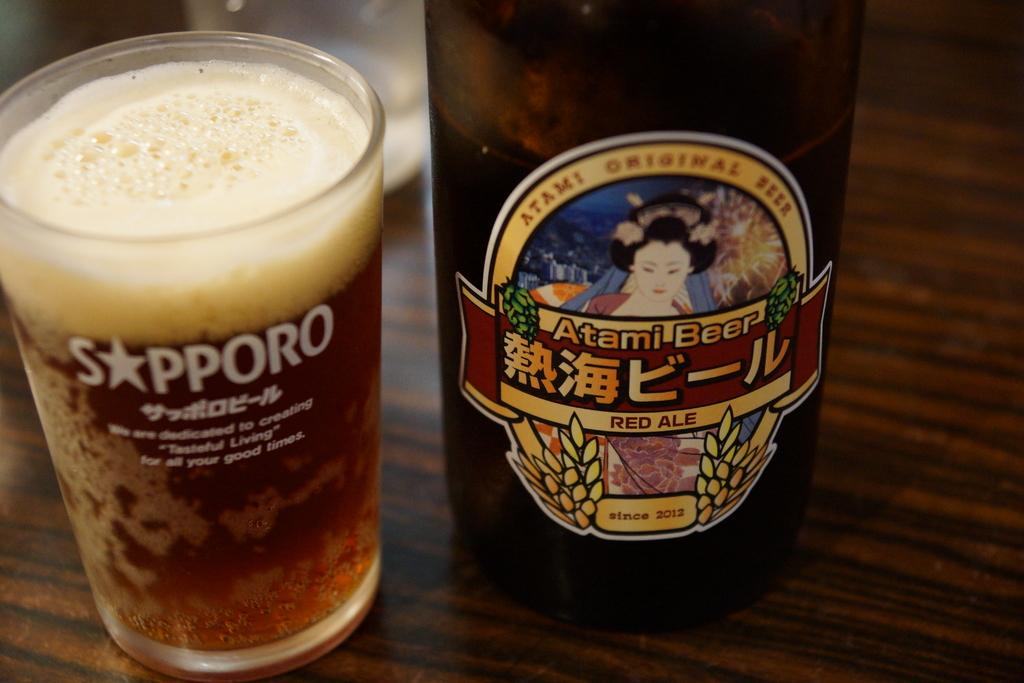What is in the glass that is visible in the image? There is a drink in the glass in the image. What else can be seen in the image besides the glass? There is a bottle in the image. Can you describe the bottle in more detail? There is a sticker on the bottle. What crime is being committed in the image? There is no crime being committed in the image; it simply shows a glass with a drink and a bottle with a sticker. What type of book is the person reading in the image? There is no person reading a book in the image; it only shows a glass with a drink and a bottle with a sticker. 